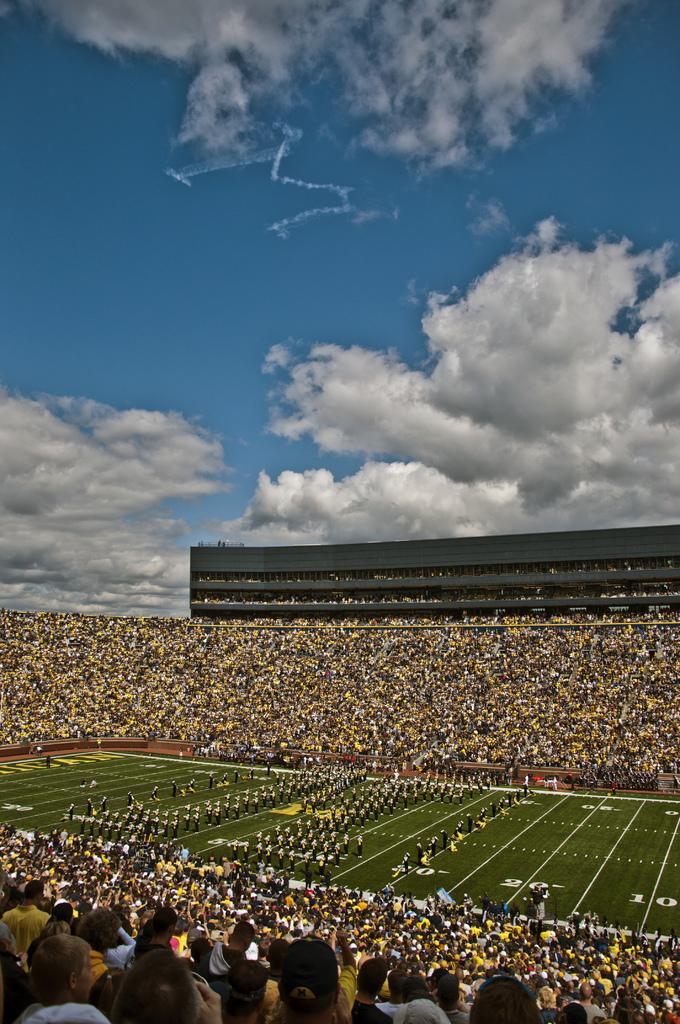Can you describe this image briefly? In the image there is a stadium and there are players standing on the ground in between the stadium and around the ground there is a huge crowd. 